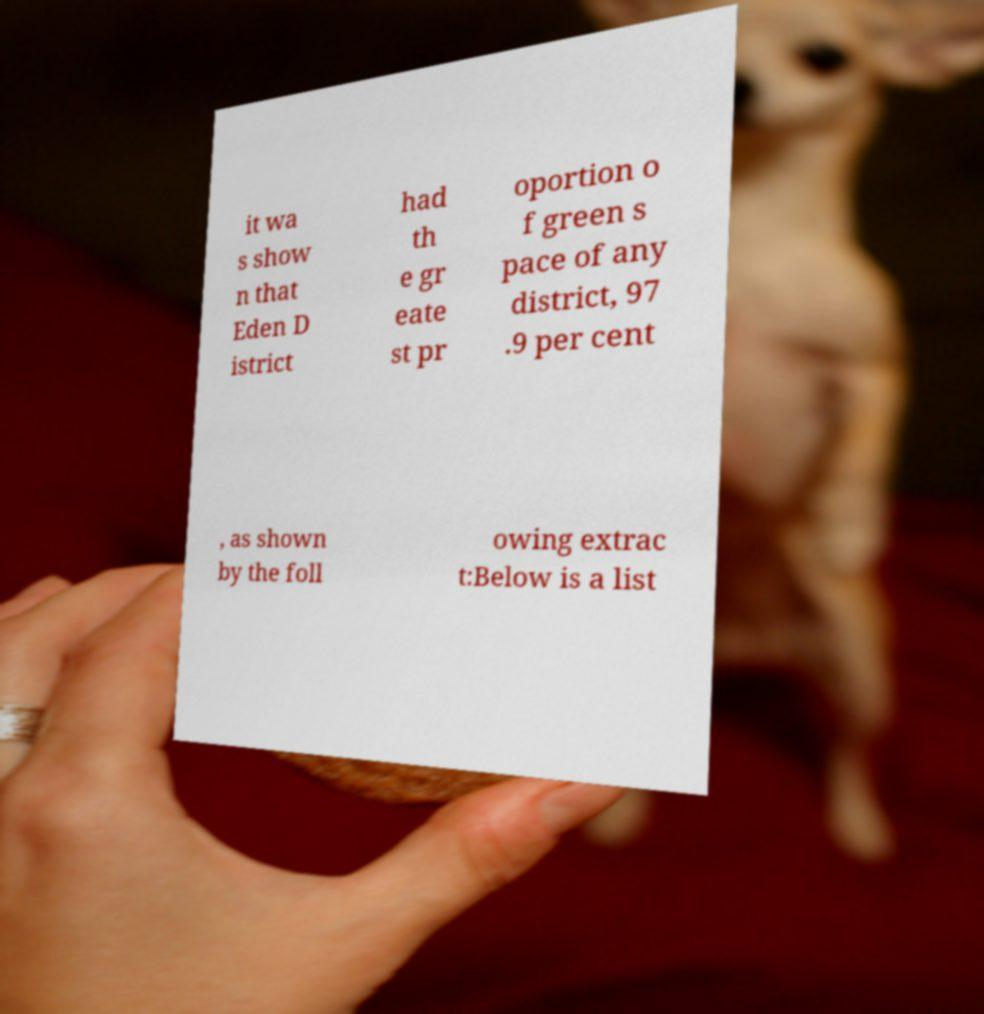Please read and relay the text visible in this image. What does it say? it wa s show n that Eden D istrict had th e gr eate st pr oportion o f green s pace of any district, 97 .9 per cent , as shown by the foll owing extrac t:Below is a list 